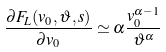<formula> <loc_0><loc_0><loc_500><loc_500>\frac { \partial F _ { L } ( v _ { 0 } , \vartheta , s ) } { \partial v _ { 0 } } \simeq \alpha \frac { v _ { 0 } ^ { \alpha - 1 } } { \vartheta ^ { \alpha } }</formula> 